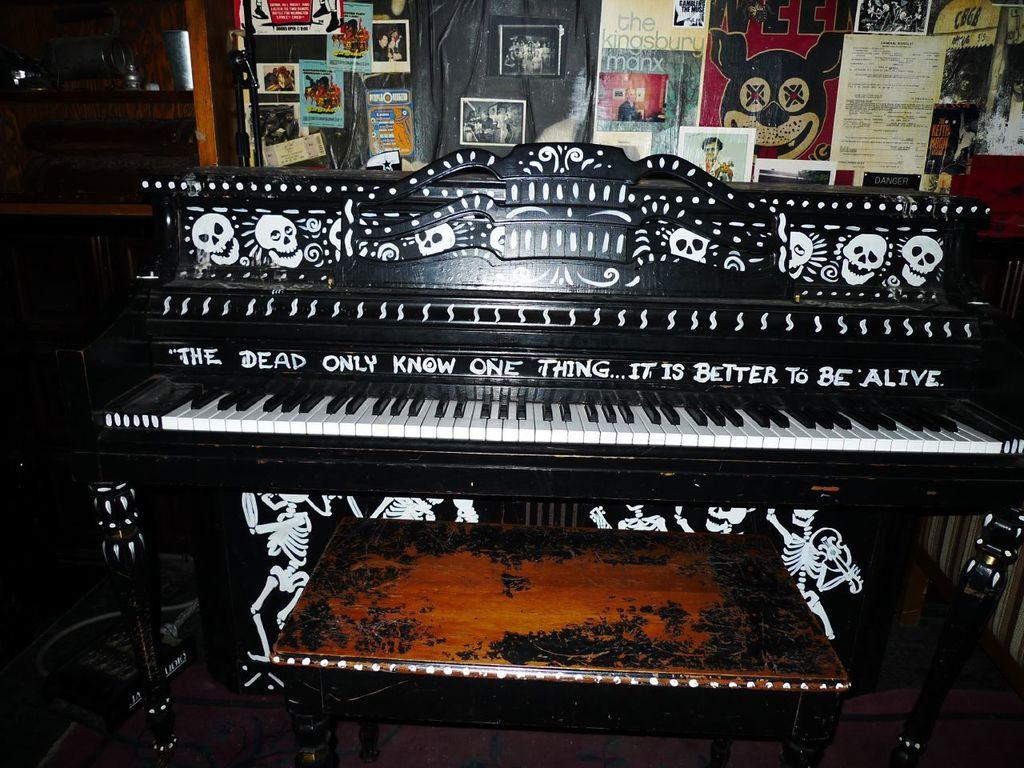What is the main object in the image? There is a piano in the image. What decorations are on the piano? There are paintings on the piano. What can be seen in the background of the image? There are posters in the background of the image. How many books are stacked on the piano in the image? There are no books visible on the piano in the image. 